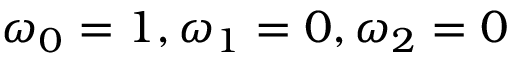<formula> <loc_0><loc_0><loc_500><loc_500>\omega _ { 0 } = 1 , \omega _ { 1 } = 0 , \omega _ { 2 } = 0</formula> 